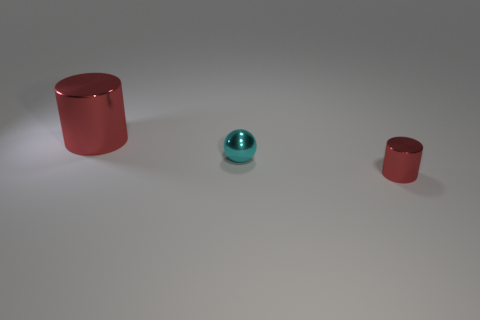Is the small cyan thing made of the same material as the small red cylinder?
Your answer should be compact. Yes. There is a cylinder on the right side of the red cylinder that is behind the tiny red shiny object; how many red shiny cylinders are left of it?
Your answer should be very brief. 1. What number of small red shiny things are there?
Provide a succinct answer. 1. Is the number of big red things that are right of the big red object less than the number of cyan things that are in front of the cyan object?
Your response must be concise. No. Is the number of cyan spheres that are on the left side of the large thing less than the number of big red cylinders?
Give a very brief answer. Yes. There is a red cylinder right of the red cylinder on the left side of the thing on the right side of the cyan object; what is its material?
Make the answer very short. Metal. How many things are either red cylinders that are behind the tiny red metal cylinder or red metal objects behind the small metal cylinder?
Your answer should be compact. 1. What is the material of the other thing that is the same shape as the large metal object?
Ensure brevity in your answer.  Metal. How many shiny objects are large purple blocks or tiny cyan things?
Your response must be concise. 1. There is a large red object that is the same material as the small cylinder; what is its shape?
Provide a succinct answer. Cylinder. 